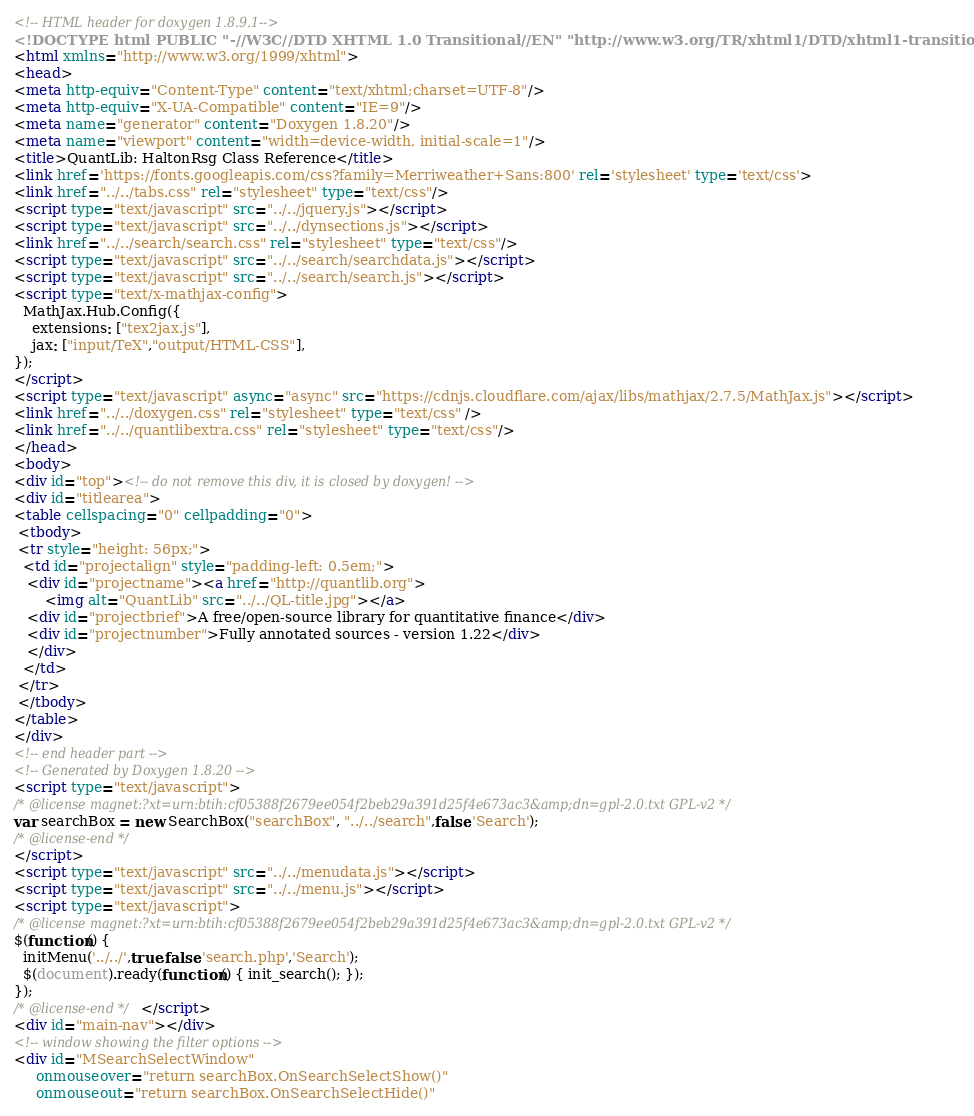Convert code to text. <code><loc_0><loc_0><loc_500><loc_500><_HTML_><!-- HTML header for doxygen 1.8.9.1-->
<!DOCTYPE html PUBLIC "-//W3C//DTD XHTML 1.0 Transitional//EN" "http://www.w3.org/TR/xhtml1/DTD/xhtml1-transitional.dtd">
<html xmlns="http://www.w3.org/1999/xhtml">
<head>
<meta http-equiv="Content-Type" content="text/xhtml;charset=UTF-8"/>
<meta http-equiv="X-UA-Compatible" content="IE=9"/>
<meta name="generator" content="Doxygen 1.8.20"/>
<meta name="viewport" content="width=device-width, initial-scale=1"/>
<title>QuantLib: HaltonRsg Class Reference</title>
<link href='https://fonts.googleapis.com/css?family=Merriweather+Sans:800' rel='stylesheet' type='text/css'>
<link href="../../tabs.css" rel="stylesheet" type="text/css"/>
<script type="text/javascript" src="../../jquery.js"></script>
<script type="text/javascript" src="../../dynsections.js"></script>
<link href="../../search/search.css" rel="stylesheet" type="text/css"/>
<script type="text/javascript" src="../../search/searchdata.js"></script>
<script type="text/javascript" src="../../search/search.js"></script>
<script type="text/x-mathjax-config">
  MathJax.Hub.Config({
    extensions: ["tex2jax.js"],
    jax: ["input/TeX","output/HTML-CSS"],
});
</script>
<script type="text/javascript" async="async" src="https://cdnjs.cloudflare.com/ajax/libs/mathjax/2.7.5/MathJax.js"></script>
<link href="../../doxygen.css" rel="stylesheet" type="text/css" />
<link href="../../quantlibextra.css" rel="stylesheet" type="text/css"/>
</head>
<body>
<div id="top"><!-- do not remove this div, it is closed by doxygen! -->
<div id="titlearea">
<table cellspacing="0" cellpadding="0">
 <tbody>
 <tr style="height: 56px;">
  <td id="projectalign" style="padding-left: 0.5em;">
   <div id="projectname"><a href="http://quantlib.org">
       <img alt="QuantLib" src="../../QL-title.jpg"></a>
   <div id="projectbrief">A free/open-source library for quantitative finance</div>
   <div id="projectnumber">Fully annotated sources - version 1.22</div>
   </div>
  </td>
 </tr>
 </tbody>
</table>
</div>
<!-- end header part -->
<!-- Generated by Doxygen 1.8.20 -->
<script type="text/javascript">
/* @license magnet:?xt=urn:btih:cf05388f2679ee054f2beb29a391d25f4e673ac3&amp;dn=gpl-2.0.txt GPL-v2 */
var searchBox = new SearchBox("searchBox", "../../search",false,'Search');
/* @license-end */
</script>
<script type="text/javascript" src="../../menudata.js"></script>
<script type="text/javascript" src="../../menu.js"></script>
<script type="text/javascript">
/* @license magnet:?xt=urn:btih:cf05388f2679ee054f2beb29a391d25f4e673ac3&amp;dn=gpl-2.0.txt GPL-v2 */
$(function() {
  initMenu('../../',true,false,'search.php','Search');
  $(document).ready(function() { init_search(); });
});
/* @license-end */</script>
<div id="main-nav"></div>
<!-- window showing the filter options -->
<div id="MSearchSelectWindow"
     onmouseover="return searchBox.OnSearchSelectShow()"
     onmouseout="return searchBox.OnSearchSelectHide()"</code> 